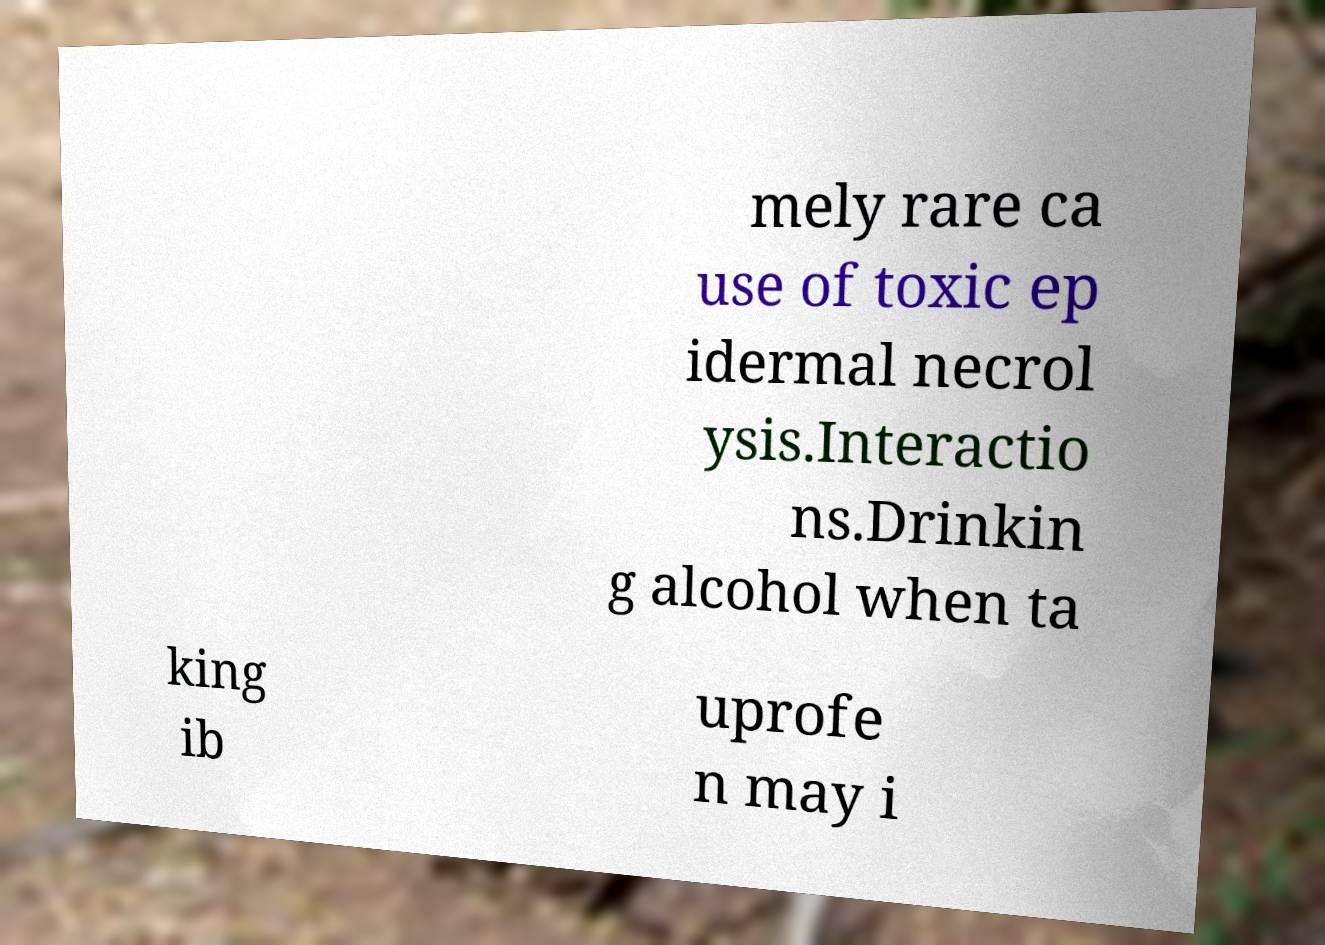Can you read and provide the text displayed in the image?This photo seems to have some interesting text. Can you extract and type it out for me? mely rare ca use of toxic ep idermal necrol ysis.Interactio ns.Drinkin g alcohol when ta king ib uprofe n may i 